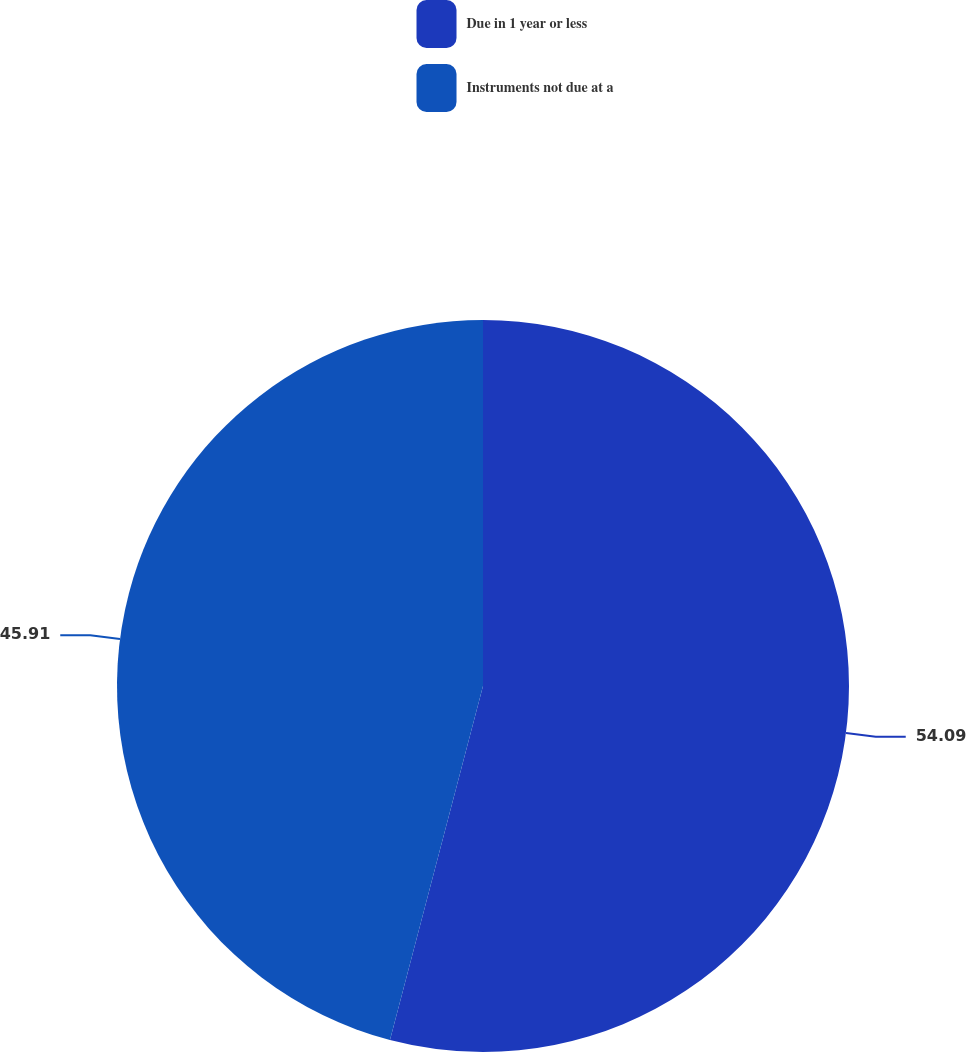Convert chart to OTSL. <chart><loc_0><loc_0><loc_500><loc_500><pie_chart><fcel>Due in 1 year or less<fcel>Instruments not due at a<nl><fcel>54.09%<fcel>45.91%<nl></chart> 